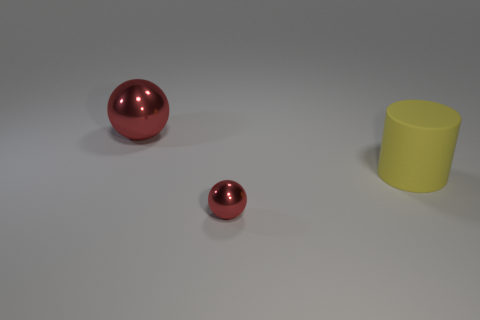Do the small metallic sphere and the rubber object have the same color?
Your answer should be compact. No. Does the red thing right of the large metal object have the same material as the big thing that is in front of the large red object?
Your answer should be very brief. No. How many objects are metal things or large objects that are behind the yellow rubber cylinder?
Offer a terse response. 2. Is there any other thing that has the same material as the large red sphere?
Offer a terse response. Yes. There is another object that is the same color as the small thing; what is its shape?
Keep it short and to the point. Sphere. What is the material of the large cylinder?
Give a very brief answer. Rubber. Is the yellow object made of the same material as the big sphere?
Your answer should be compact. No. How many shiny objects are either small red balls or yellow cylinders?
Provide a short and direct response. 1. What is the shape of the metal thing behind the large rubber thing?
Your answer should be compact. Sphere. There is another red ball that is made of the same material as the tiny red sphere; what size is it?
Keep it short and to the point. Large. 